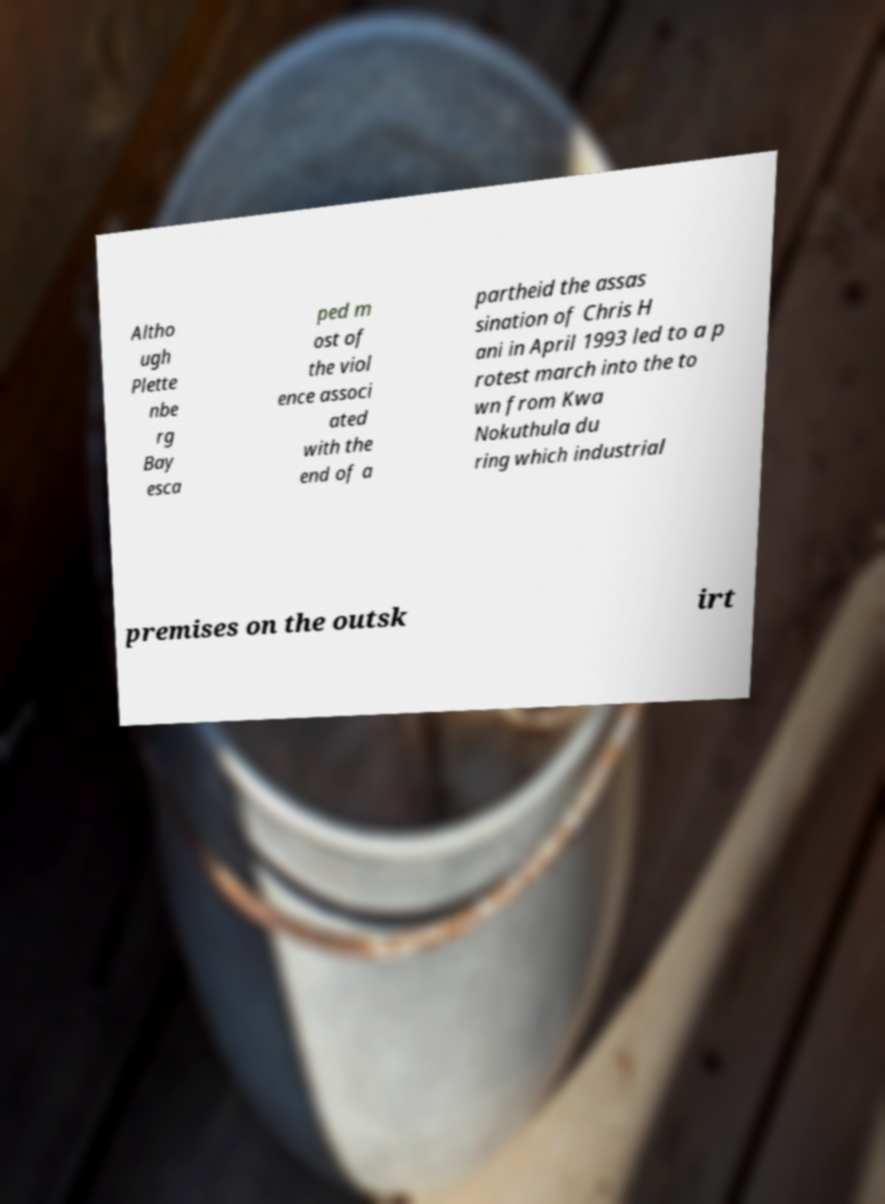Could you extract and type out the text from this image? Altho ugh Plette nbe rg Bay esca ped m ost of the viol ence associ ated with the end of a partheid the assas sination of Chris H ani in April 1993 led to a p rotest march into the to wn from Kwa Nokuthula du ring which industrial premises on the outsk irt 